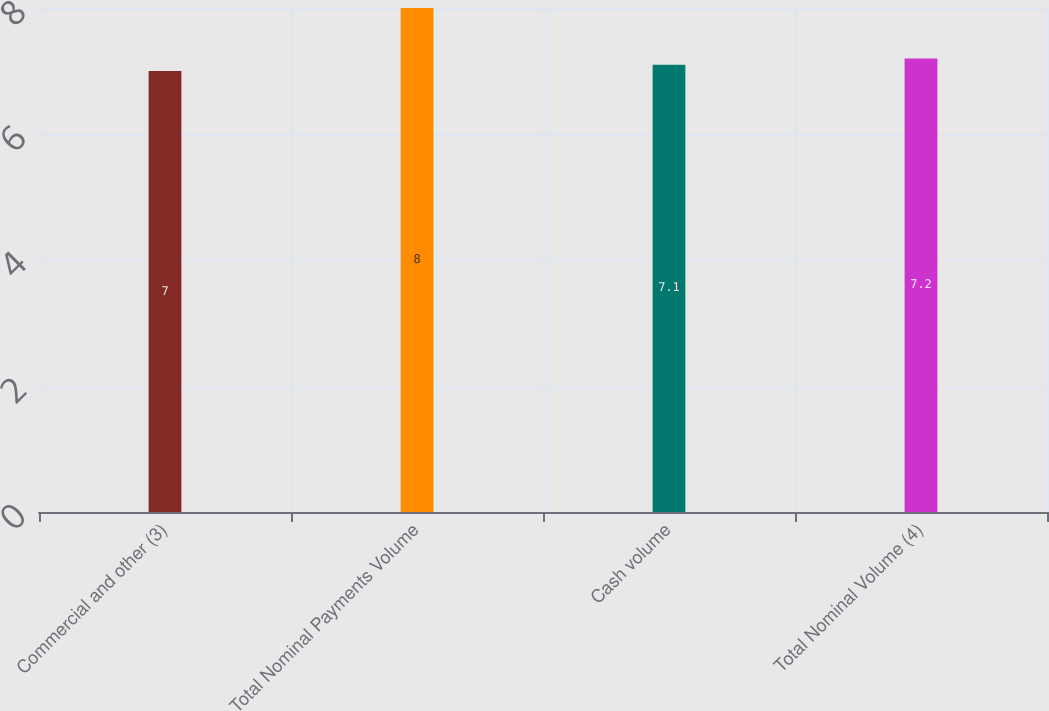<chart> <loc_0><loc_0><loc_500><loc_500><bar_chart><fcel>Commercial and other (3)<fcel>Total Nominal Payments Volume<fcel>Cash volume<fcel>Total Nominal Volume (4)<nl><fcel>7<fcel>8<fcel>7.1<fcel>7.2<nl></chart> 